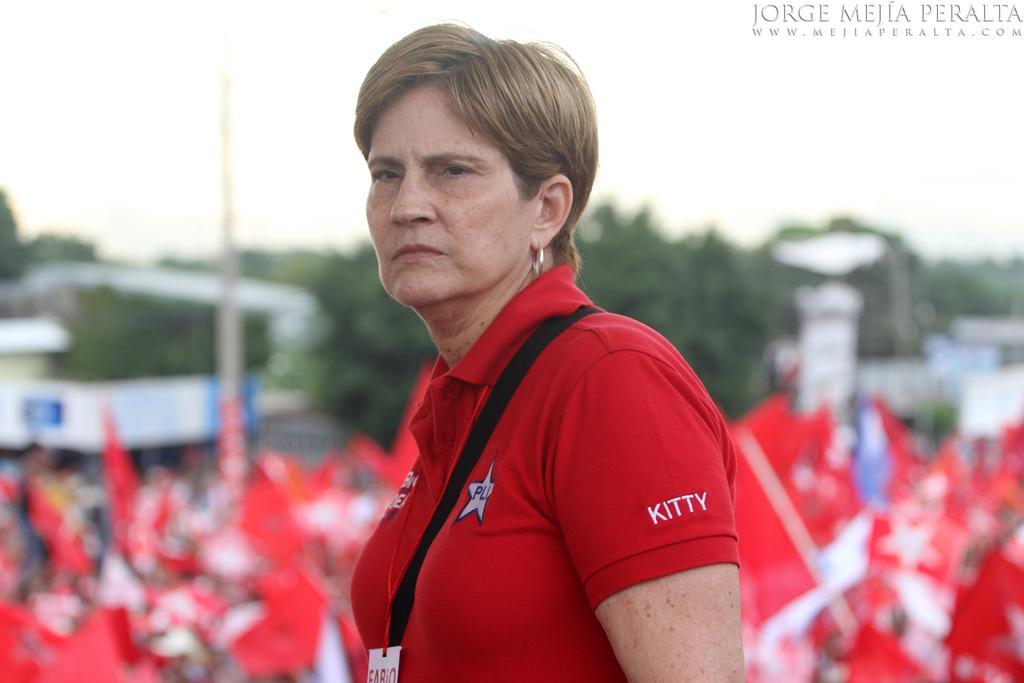Can you describe this image briefly? The image is taken outside a city. In the foreground of the picture there is a woman in red t-shirt. The background is blurred. In the center of the picture there are red color flags, trees and buildings. 